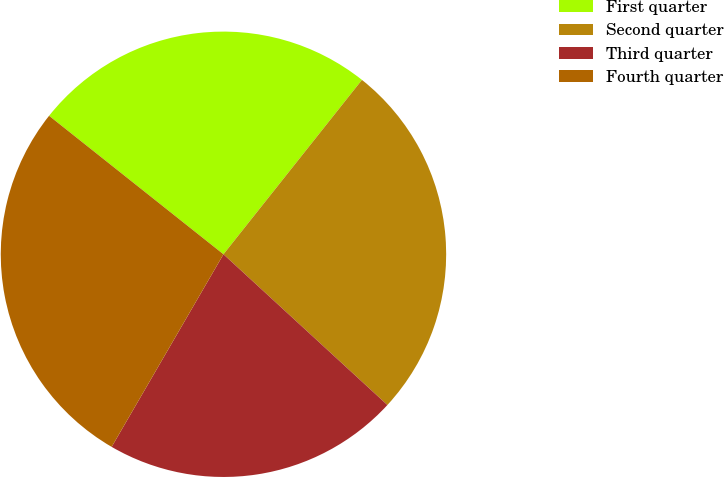Convert chart. <chart><loc_0><loc_0><loc_500><loc_500><pie_chart><fcel>First quarter<fcel>Second quarter<fcel>Third quarter<fcel>Fourth quarter<nl><fcel>25.0%<fcel>26.15%<fcel>21.54%<fcel>27.31%<nl></chart> 